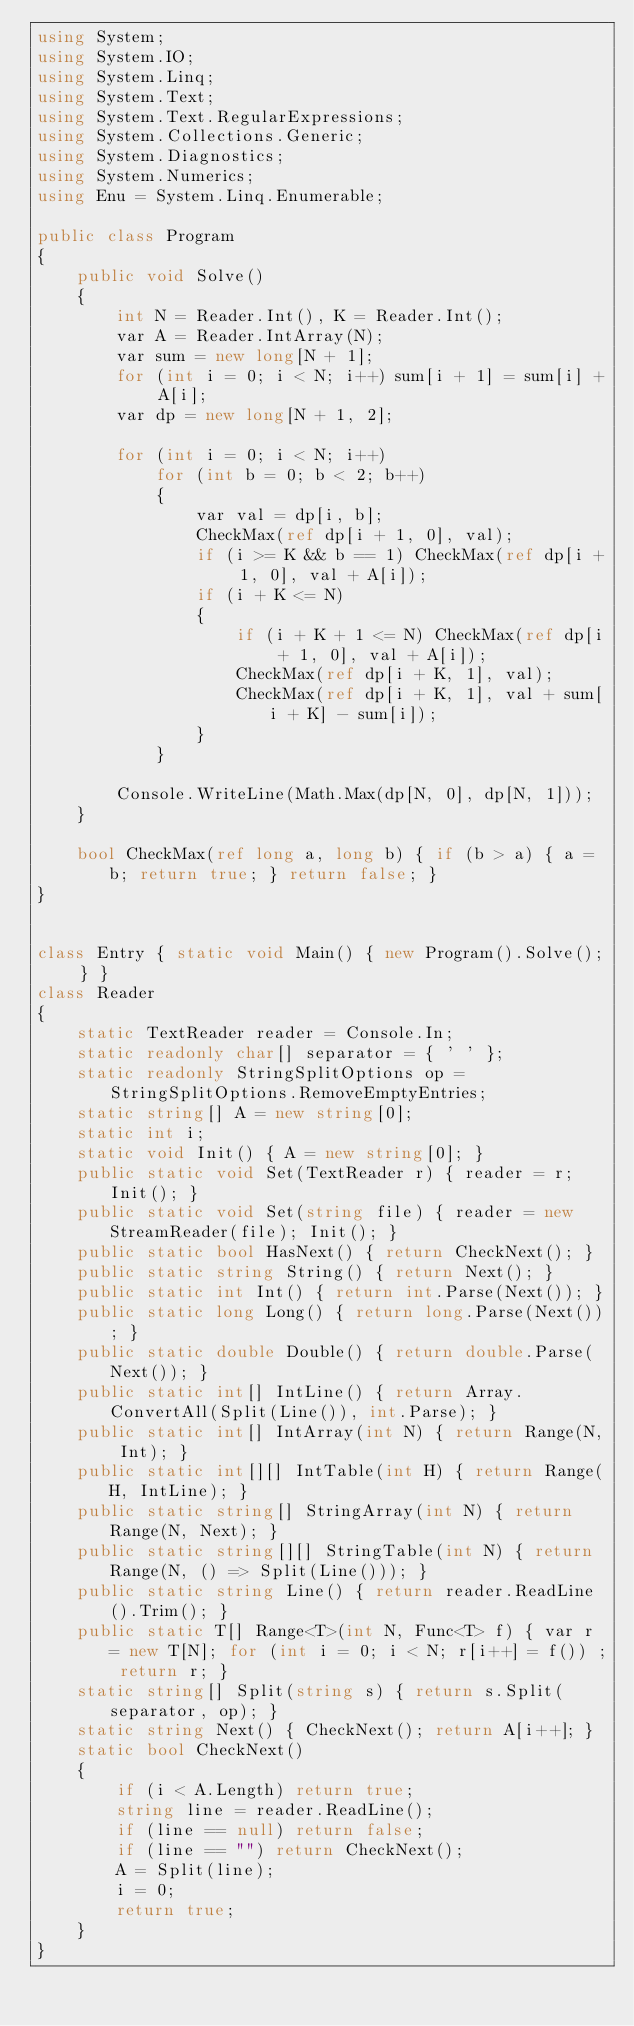Convert code to text. <code><loc_0><loc_0><loc_500><loc_500><_C#_>using System;
using System.IO;
using System.Linq;
using System.Text;
using System.Text.RegularExpressions;
using System.Collections.Generic;
using System.Diagnostics;
using System.Numerics;
using Enu = System.Linq.Enumerable;

public class Program
{
    public void Solve()
    {
        int N = Reader.Int(), K = Reader.Int();
        var A = Reader.IntArray(N);
        var sum = new long[N + 1];
        for (int i = 0; i < N; i++) sum[i + 1] = sum[i] + A[i];
        var dp = new long[N + 1, 2];

        for (int i = 0; i < N; i++)
            for (int b = 0; b < 2; b++)
            {
                var val = dp[i, b];
                CheckMax(ref dp[i + 1, 0], val);
                if (i >= K && b == 1) CheckMax(ref dp[i + 1, 0], val + A[i]);
                if (i + K <= N)
                {
                    if (i + K + 1 <= N) CheckMax(ref dp[i + 1, 0], val + A[i]);
                    CheckMax(ref dp[i + K, 1], val);
                    CheckMax(ref dp[i + K, 1], val + sum[i + K] - sum[i]);
                }
            }

        Console.WriteLine(Math.Max(dp[N, 0], dp[N, 1]));
    }

    bool CheckMax(ref long a, long b) { if (b > a) { a = b; return true; } return false; }
}


class Entry { static void Main() { new Program().Solve(); } }
class Reader
{
    static TextReader reader = Console.In;
    static readonly char[] separator = { ' ' };
    static readonly StringSplitOptions op = StringSplitOptions.RemoveEmptyEntries;
    static string[] A = new string[0];
    static int i;
    static void Init() { A = new string[0]; }
    public static void Set(TextReader r) { reader = r; Init(); }
    public static void Set(string file) { reader = new StreamReader(file); Init(); }
    public static bool HasNext() { return CheckNext(); }
    public static string String() { return Next(); }
    public static int Int() { return int.Parse(Next()); }
    public static long Long() { return long.Parse(Next()); }
    public static double Double() { return double.Parse(Next()); }
    public static int[] IntLine() { return Array.ConvertAll(Split(Line()), int.Parse); }
    public static int[] IntArray(int N) { return Range(N, Int); }
    public static int[][] IntTable(int H) { return Range(H, IntLine); }
    public static string[] StringArray(int N) { return Range(N, Next); }
    public static string[][] StringTable(int N) { return Range(N, () => Split(Line())); }
    public static string Line() { return reader.ReadLine().Trim(); }
    public static T[] Range<T>(int N, Func<T> f) { var r = new T[N]; for (int i = 0; i < N; r[i++] = f()) ; return r; }
    static string[] Split(string s) { return s.Split(separator, op); }
    static string Next() { CheckNext(); return A[i++]; }
    static bool CheckNext()
    {
        if (i < A.Length) return true;
        string line = reader.ReadLine();
        if (line == null) return false;
        if (line == "") return CheckNext();
        A = Split(line);
        i = 0;
        return true;
    }
}</code> 